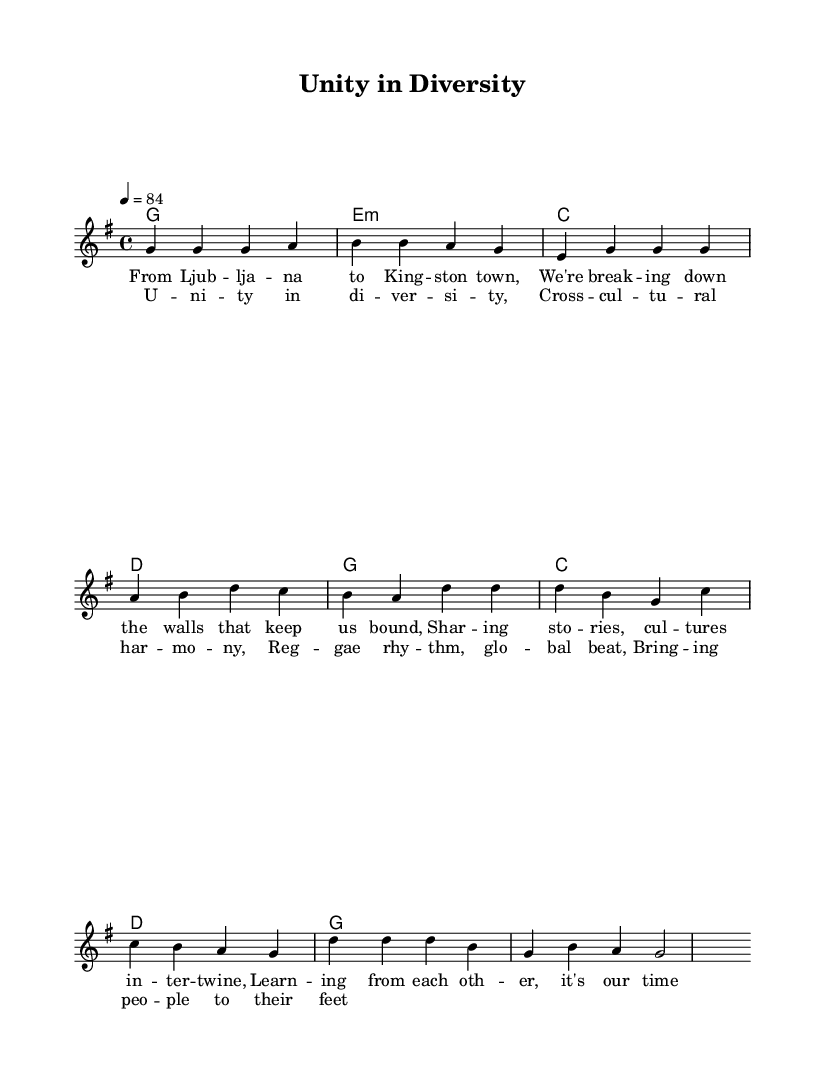What is the key signature of this music? The key signature is G major, which has one sharp, indicated by the presence of an F# in the scale. This is usually seen at the beginning of the score.
Answer: G major What is the time signature of the piece? The time signature is 4/4, which is indicated at the beginning of the score. It shows that there are four beats in each measure and a quarter note receives one beat.
Answer: 4/4 What is the tempo marking of this composition? The tempo marking indicates a speed of 84 beats per minute, noted in the score as "4 = 84". This tells the performer how fast to play the piece.
Answer: 84 How many measures are in the verse? To determine the number of measures in the verse, we can count the distinct phrases written in the score. The verse portion contains four measures.
Answer: 4 What thematic message does the chorus express? The chorus conveys a message of unity and understanding across different cultures, highlighted in the lyrics which speak to "Unity in diversity" and "Cross-cultural harmony". This reflects a central theme in reggae music.
Answer: Unity in diversity How does the harmonic progression in the chorus contribute to the reggae style? The harmonic progression in the chorus uses simple triadic chords (G, C, D), which are common in reggae music. This simplicity allows the rhythm and vocals to stand out, reinforcing the upbeat and inclusive feel typical of the genre.
Answer: Simple triadic chords 